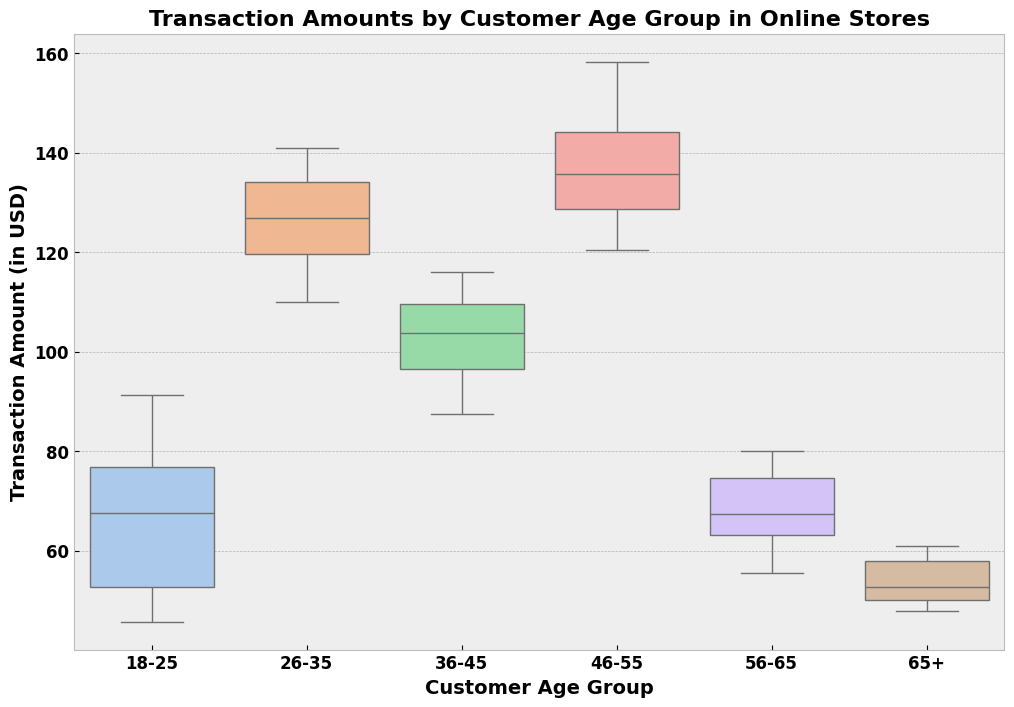What is the median transaction amount for the 36-45 age group? The median is the middle value when the transaction amounts are ordered from least to greatest. In the 36-45 age group, arrange the transaction amounts and identify the middle value.
Answer: 105.75 Which age group has the highest range of transaction amounts? The range is the difference between the maximum and minimum transaction amounts in each age group. By comparing the differences, determine the highest range.
Answer: 46-55 Is the interquartile range (IQR) for the 26-35 age group greater than that for the 18-25 age group? The IQR is the difference between the first quartile (Q1) and the third quartile (Q3). Calculate the IQR for both age groups and compare them.
Answer: Yes What is the highest transaction amount recorded for the 18-25 age group? Identify the maximum value from the transaction amounts in the 18-25 age group.
Answer: 91.20 Compare the median transaction amounts between the 46-55 and 56-65 age groups. Which one is higher? Identify the median for each age group and compare them to see which is higher.
Answer: 46-55 How does the spread of transaction amounts for the 56-65 age group compare visually to that of the 65+ age group? Observe the length of the boxes and whiskers for both age groups to compare the spread (variability).
Answer: 56-65 has a wider spread Which age group has the smallest median transaction amount? Identify the median transaction amount for each age group and determine the smallest one.
Answer: 65+ What is the difference between the third quartile (Q3) values of the 26-35 and 46-55 age groups? Calculate the third quartile value for both age groups and find the difference between them.
Answer: About 5 Do the 26-35 and 46-55 age groups show any overlapping in their transaction amount ranges? Compare the ranges (minimum and maximum) of transaction amounts between the two age groups to see if there's any overlap.
Answer: Yes 